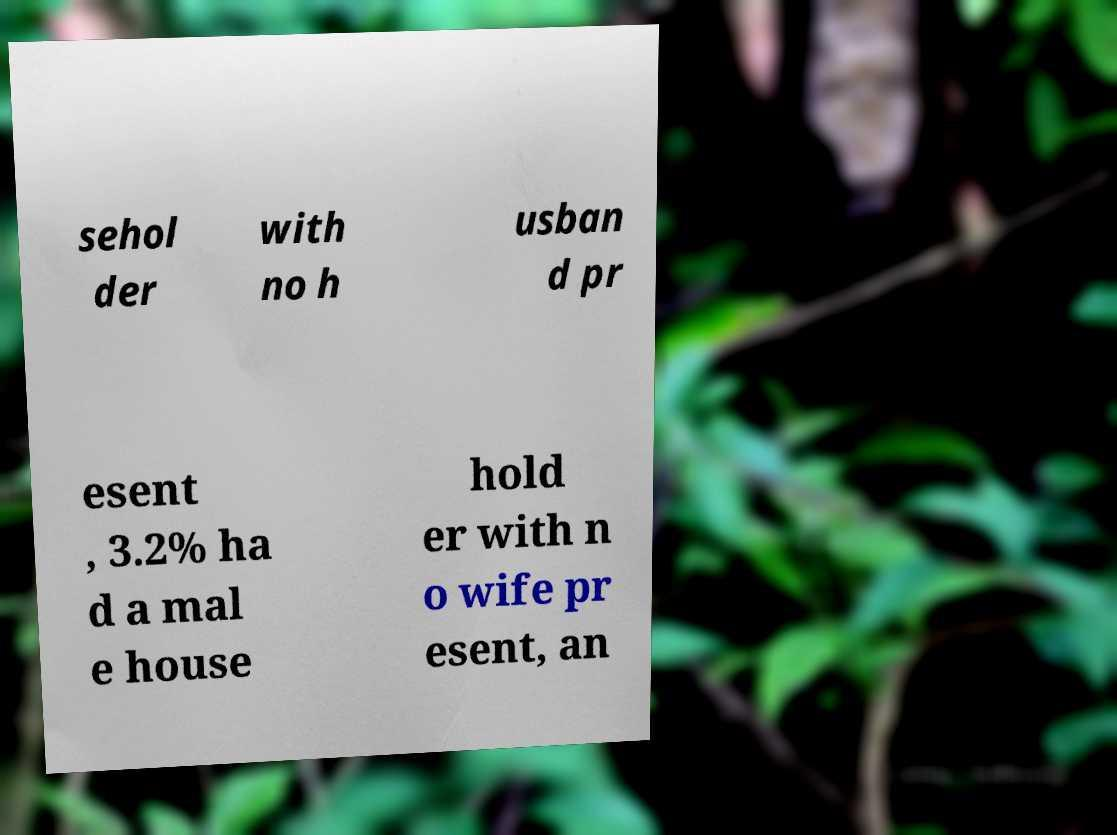Can you read and provide the text displayed in the image?This photo seems to have some interesting text. Can you extract and type it out for me? sehol der with no h usban d pr esent , 3.2% ha d a mal e house hold er with n o wife pr esent, an 